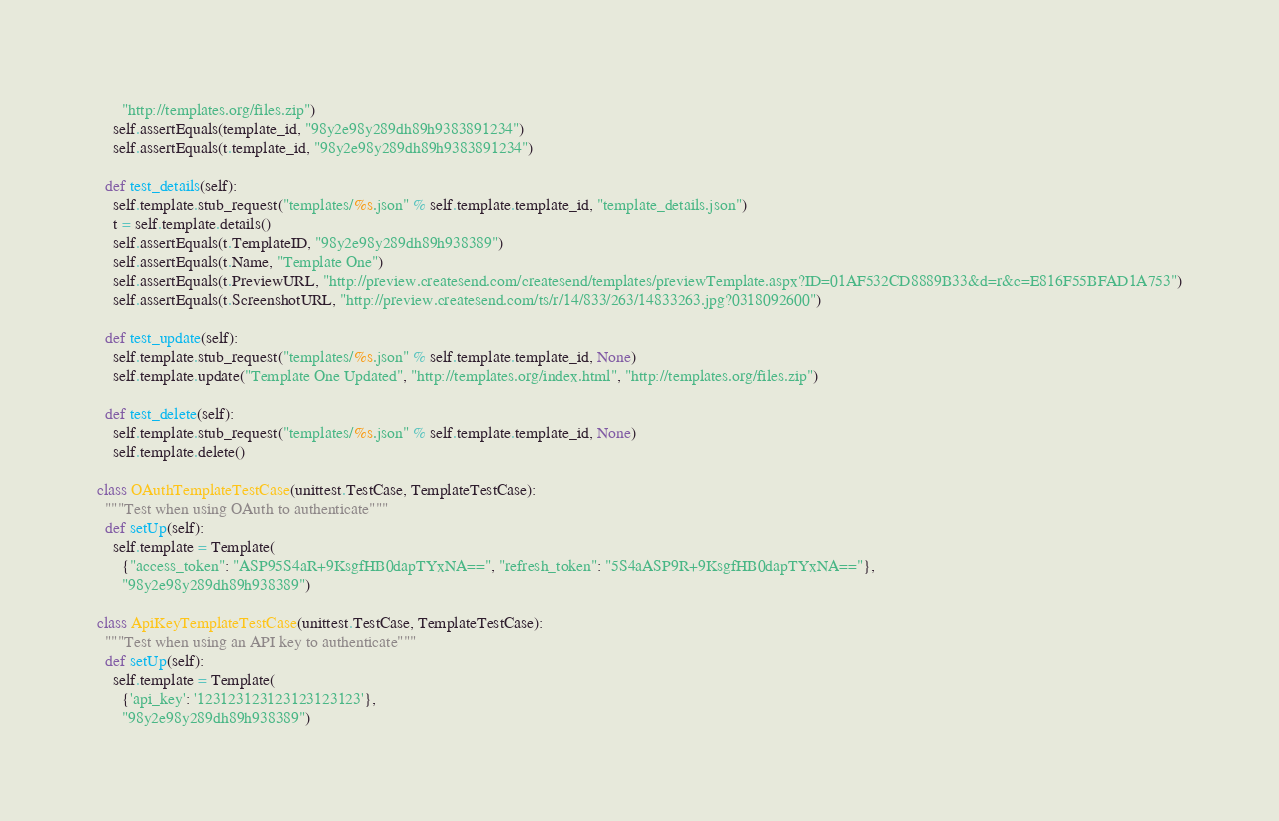<code> <loc_0><loc_0><loc_500><loc_500><_Python_>      "http://templates.org/files.zip")
    self.assertEquals(template_id, "98y2e98y289dh89h9383891234")
    self.assertEquals(t.template_id, "98y2e98y289dh89h9383891234")

  def test_details(self):
    self.template.stub_request("templates/%s.json" % self.template.template_id, "template_details.json")
    t = self.template.details()
    self.assertEquals(t.TemplateID, "98y2e98y289dh89h938389")
    self.assertEquals(t.Name, "Template One")
    self.assertEquals(t.PreviewURL, "http://preview.createsend.com/createsend/templates/previewTemplate.aspx?ID=01AF532CD8889B33&d=r&c=E816F55BFAD1A753")
    self.assertEquals(t.ScreenshotURL, "http://preview.createsend.com/ts/r/14/833/263/14833263.jpg?0318092600")

  def test_update(self):
    self.template.stub_request("templates/%s.json" % self.template.template_id, None)
    self.template.update("Template One Updated", "http://templates.org/index.html", "http://templates.org/files.zip")
  
  def test_delete(self):
    self.template.stub_request("templates/%s.json" % self.template.template_id, None)
    self.template.delete()

class OAuthTemplateTestCase(unittest.TestCase, TemplateTestCase):
  """Test when using OAuth to authenticate"""
  def setUp(self):
    self.template = Template(
      {"access_token": "ASP95S4aR+9KsgfHB0dapTYxNA==", "refresh_token": "5S4aASP9R+9KsgfHB0dapTYxNA=="},
      "98y2e98y289dh89h938389")

class ApiKeyTemplateTestCase(unittest.TestCase, TemplateTestCase):
  """Test when using an API key to authenticate"""
  def setUp(self):
    self.template = Template(
      {'api_key': '123123123123123123123'},
      "98y2e98y289dh89h938389")
</code> 